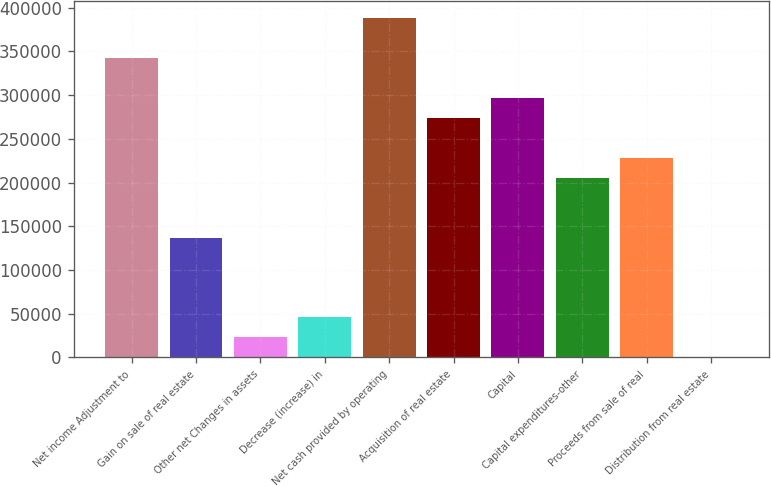Convert chart. <chart><loc_0><loc_0><loc_500><loc_500><bar_chart><fcel>Net income Adjustment to<fcel>Gain on sale of real estate<fcel>Other net Changes in assets<fcel>Decrease (increase) in<fcel>Net cash provided by operating<fcel>Acquisition of real estate<fcel>Capital<fcel>Capital expenditures-other<fcel>Proceeds from sale of real<fcel>Distribution from real estate<nl><fcel>342246<fcel>137116<fcel>23155.2<fcel>45947.4<fcel>387830<fcel>273869<fcel>296662<fcel>205493<fcel>228285<fcel>363<nl></chart> 